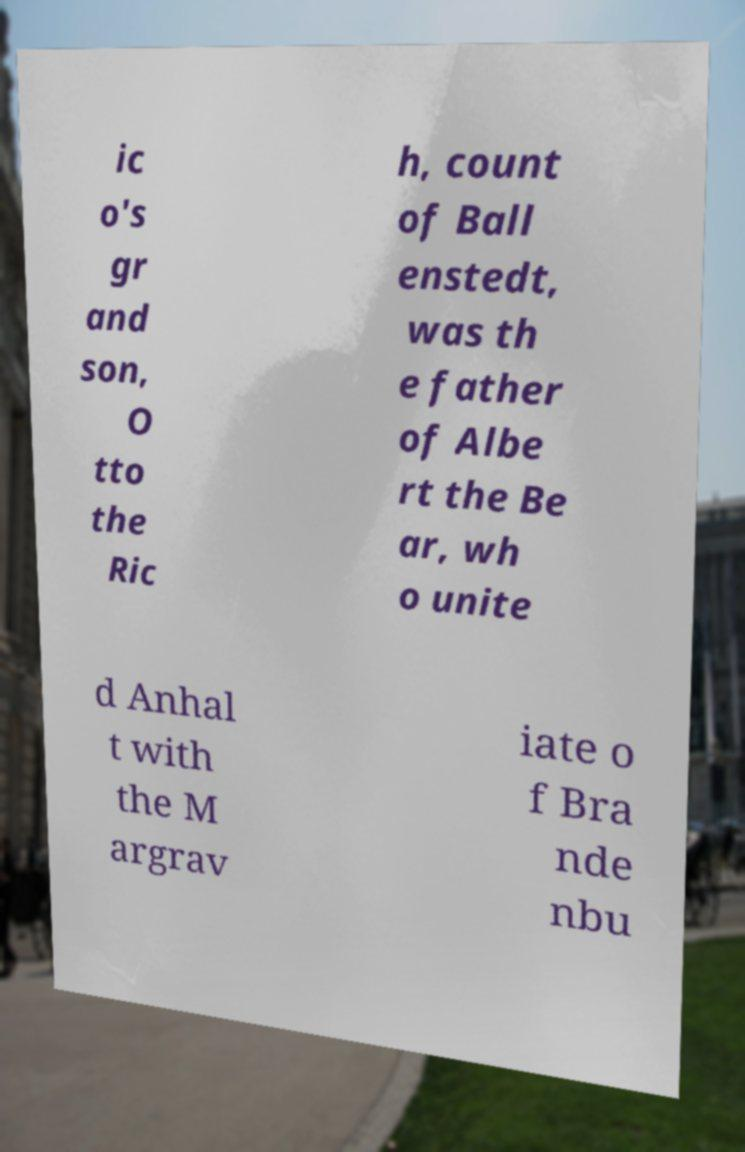Please read and relay the text visible in this image. What does it say? ic o's gr and son, O tto the Ric h, count of Ball enstedt, was th e father of Albe rt the Be ar, wh o unite d Anhal t with the M argrav iate o f Bra nde nbu 